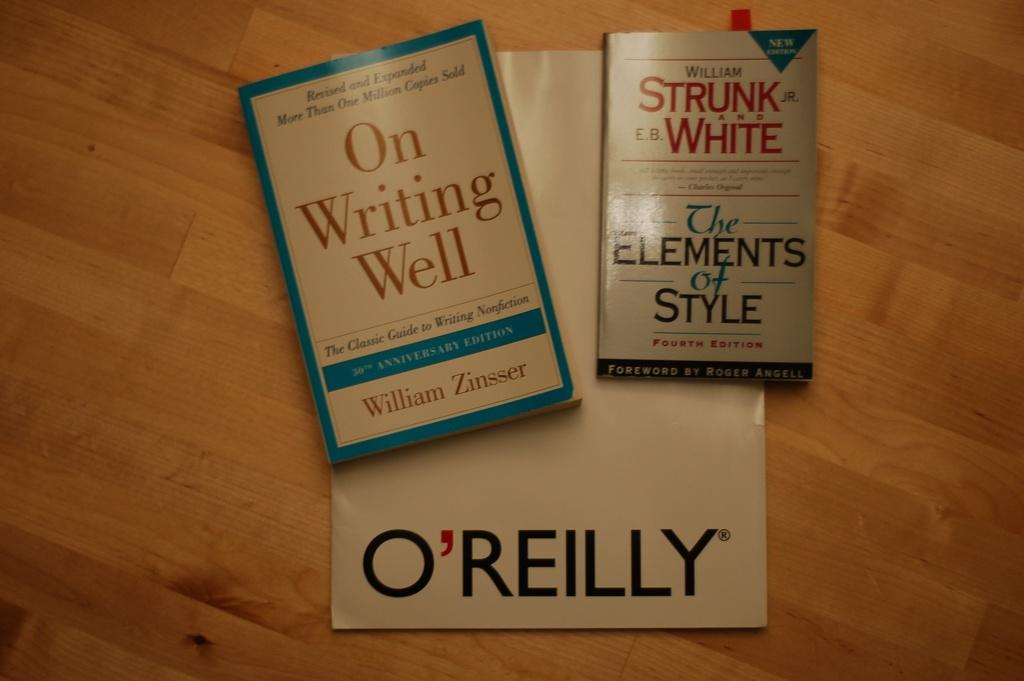Provide a one-sentence caption for the provided image. Two books sit on a table, and under them sits a piece of paper with the name O'Reilly. 